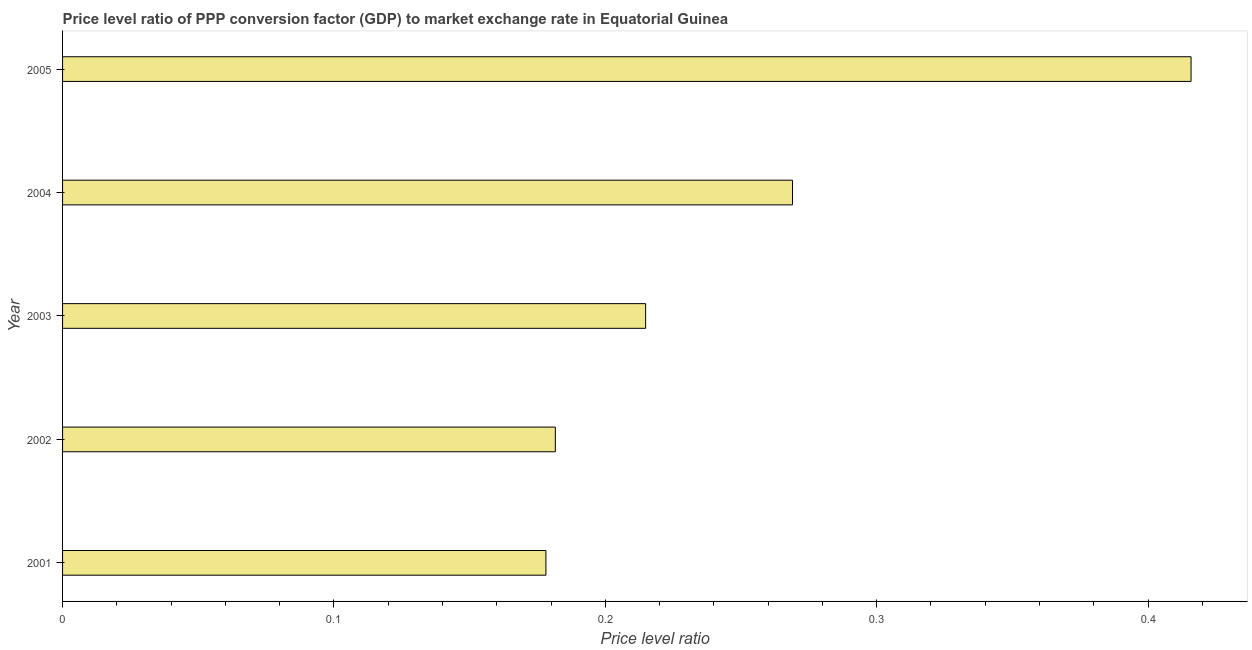Does the graph contain any zero values?
Keep it short and to the point. No. Does the graph contain grids?
Provide a short and direct response. No. What is the title of the graph?
Offer a very short reply. Price level ratio of PPP conversion factor (GDP) to market exchange rate in Equatorial Guinea. What is the label or title of the X-axis?
Offer a very short reply. Price level ratio. What is the price level ratio in 2002?
Keep it short and to the point. 0.18. Across all years, what is the maximum price level ratio?
Ensure brevity in your answer.  0.42. Across all years, what is the minimum price level ratio?
Your answer should be compact. 0.18. What is the sum of the price level ratio?
Keep it short and to the point. 1.26. What is the difference between the price level ratio in 2004 and 2005?
Your answer should be very brief. -0.15. What is the average price level ratio per year?
Make the answer very short. 0.25. What is the median price level ratio?
Offer a terse response. 0.21. In how many years, is the price level ratio greater than 0.18 ?
Offer a terse response. 4. Do a majority of the years between 2002 and 2004 (inclusive) have price level ratio greater than 0.04 ?
Make the answer very short. Yes. What is the ratio of the price level ratio in 2002 to that in 2004?
Ensure brevity in your answer.  0.68. What is the difference between the highest and the second highest price level ratio?
Ensure brevity in your answer.  0.15. What is the difference between the highest and the lowest price level ratio?
Make the answer very short. 0.24. How many bars are there?
Offer a terse response. 5. How many years are there in the graph?
Offer a very short reply. 5. What is the difference between two consecutive major ticks on the X-axis?
Your response must be concise. 0.1. Are the values on the major ticks of X-axis written in scientific E-notation?
Offer a terse response. No. What is the Price level ratio of 2001?
Give a very brief answer. 0.18. What is the Price level ratio in 2002?
Offer a terse response. 0.18. What is the Price level ratio in 2003?
Make the answer very short. 0.21. What is the Price level ratio of 2004?
Your answer should be very brief. 0.27. What is the Price level ratio of 2005?
Your response must be concise. 0.42. What is the difference between the Price level ratio in 2001 and 2002?
Your response must be concise. -0. What is the difference between the Price level ratio in 2001 and 2003?
Your answer should be very brief. -0.04. What is the difference between the Price level ratio in 2001 and 2004?
Give a very brief answer. -0.09. What is the difference between the Price level ratio in 2001 and 2005?
Your answer should be compact. -0.24. What is the difference between the Price level ratio in 2002 and 2003?
Provide a succinct answer. -0.03. What is the difference between the Price level ratio in 2002 and 2004?
Ensure brevity in your answer.  -0.09. What is the difference between the Price level ratio in 2002 and 2005?
Keep it short and to the point. -0.23. What is the difference between the Price level ratio in 2003 and 2004?
Your answer should be very brief. -0.05. What is the difference between the Price level ratio in 2003 and 2005?
Offer a very short reply. -0.2. What is the difference between the Price level ratio in 2004 and 2005?
Offer a very short reply. -0.15. What is the ratio of the Price level ratio in 2001 to that in 2003?
Provide a succinct answer. 0.83. What is the ratio of the Price level ratio in 2001 to that in 2004?
Your answer should be very brief. 0.66. What is the ratio of the Price level ratio in 2001 to that in 2005?
Provide a short and direct response. 0.43. What is the ratio of the Price level ratio in 2002 to that in 2003?
Your answer should be very brief. 0.84. What is the ratio of the Price level ratio in 2002 to that in 2004?
Offer a very short reply. 0.68. What is the ratio of the Price level ratio in 2002 to that in 2005?
Provide a short and direct response. 0.44. What is the ratio of the Price level ratio in 2003 to that in 2004?
Keep it short and to the point. 0.8. What is the ratio of the Price level ratio in 2003 to that in 2005?
Give a very brief answer. 0.52. What is the ratio of the Price level ratio in 2004 to that in 2005?
Offer a terse response. 0.65. 